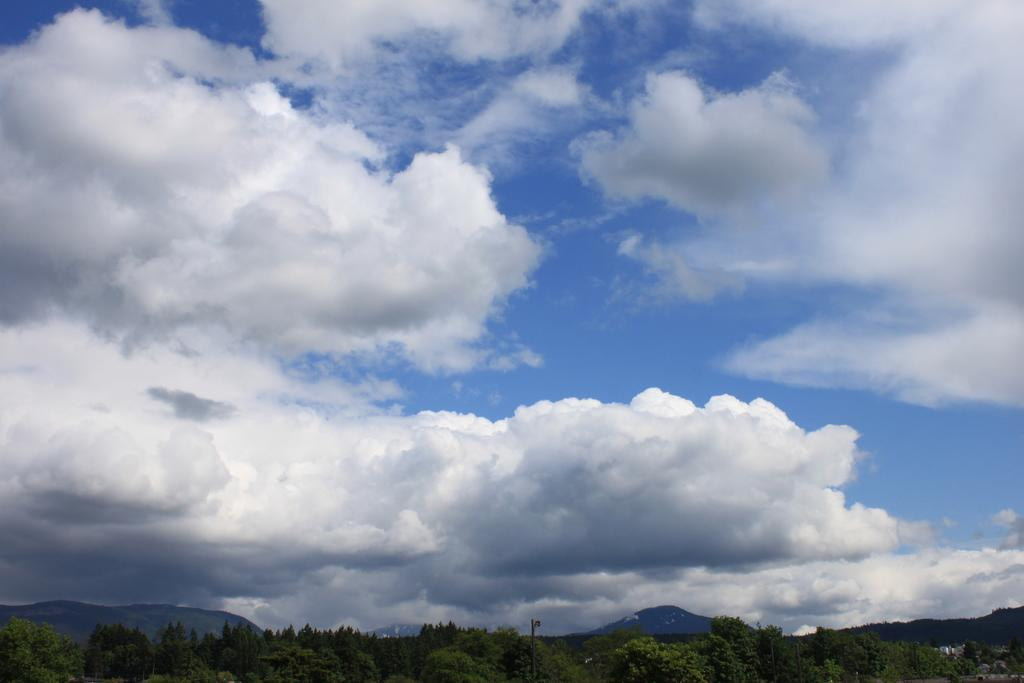What type of vegetation is at the bottom of the image? There are trees at the bottom of the image. What can be seen in the sky in the image? There are clouds in the sky in the image. What geographical features are in the middle of the image? There are hills in the middle of the image. What type of friction can be observed between the clouds and the hills in the image? There is no friction between the clouds and the hills in the image, as they are separate elements in the scene. What message of peace is conveyed by the image? The image does not convey a specific message of peace, as it is a landscape scene without any text or symbolism related to peace. 